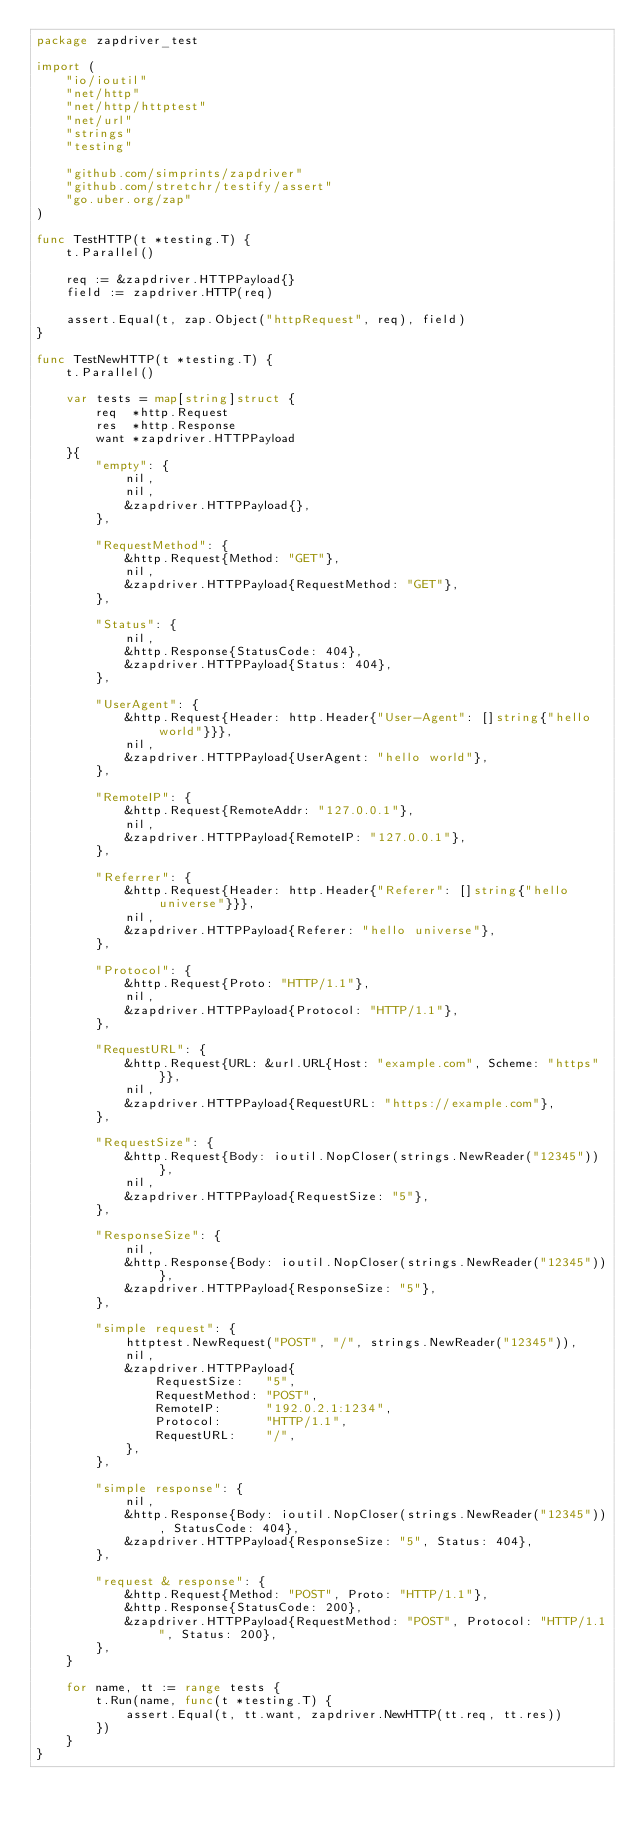<code> <loc_0><loc_0><loc_500><loc_500><_Go_>package zapdriver_test

import (
	"io/ioutil"
	"net/http"
	"net/http/httptest"
	"net/url"
	"strings"
	"testing"

	"github.com/simprints/zapdriver"
	"github.com/stretchr/testify/assert"
	"go.uber.org/zap"
)

func TestHTTP(t *testing.T) {
	t.Parallel()

	req := &zapdriver.HTTPPayload{}
	field := zapdriver.HTTP(req)

	assert.Equal(t, zap.Object("httpRequest", req), field)
}

func TestNewHTTP(t *testing.T) {
	t.Parallel()

	var tests = map[string]struct {
		req  *http.Request
		res  *http.Response
		want *zapdriver.HTTPPayload
	}{
		"empty": {
			nil,
			nil,
			&zapdriver.HTTPPayload{},
		},

		"RequestMethod": {
			&http.Request{Method: "GET"},
			nil,
			&zapdriver.HTTPPayload{RequestMethod: "GET"},
		},

		"Status": {
			nil,
			&http.Response{StatusCode: 404},
			&zapdriver.HTTPPayload{Status: 404},
		},

		"UserAgent": {
			&http.Request{Header: http.Header{"User-Agent": []string{"hello world"}}},
			nil,
			&zapdriver.HTTPPayload{UserAgent: "hello world"},
		},

		"RemoteIP": {
			&http.Request{RemoteAddr: "127.0.0.1"},
			nil,
			&zapdriver.HTTPPayload{RemoteIP: "127.0.0.1"},
		},

		"Referrer": {
			&http.Request{Header: http.Header{"Referer": []string{"hello universe"}}},
			nil,
			&zapdriver.HTTPPayload{Referer: "hello universe"},
		},

		"Protocol": {
			&http.Request{Proto: "HTTP/1.1"},
			nil,
			&zapdriver.HTTPPayload{Protocol: "HTTP/1.1"},
		},

		"RequestURL": {
			&http.Request{URL: &url.URL{Host: "example.com", Scheme: "https"}},
			nil,
			&zapdriver.HTTPPayload{RequestURL: "https://example.com"},
		},

		"RequestSize": {
			&http.Request{Body: ioutil.NopCloser(strings.NewReader("12345"))},
			nil,
			&zapdriver.HTTPPayload{RequestSize: "5"},
		},

		"ResponseSize": {
			nil,
			&http.Response{Body: ioutil.NopCloser(strings.NewReader("12345"))},
			&zapdriver.HTTPPayload{ResponseSize: "5"},
		},

		"simple request": {
			httptest.NewRequest("POST", "/", strings.NewReader("12345")),
			nil,
			&zapdriver.HTTPPayload{
				RequestSize:   "5",
				RequestMethod: "POST",
				RemoteIP:      "192.0.2.1:1234",
				Protocol:      "HTTP/1.1",
				RequestURL:    "/",
			},
		},

		"simple response": {
			nil,
			&http.Response{Body: ioutil.NopCloser(strings.NewReader("12345")), StatusCode: 404},
			&zapdriver.HTTPPayload{ResponseSize: "5", Status: 404},
		},

		"request & response": {
			&http.Request{Method: "POST", Proto: "HTTP/1.1"},
			&http.Response{StatusCode: 200},
			&zapdriver.HTTPPayload{RequestMethod: "POST", Protocol: "HTTP/1.1", Status: 200},
		},
	}

	for name, tt := range tests {
		t.Run(name, func(t *testing.T) {
			assert.Equal(t, tt.want, zapdriver.NewHTTP(tt.req, tt.res))
		})
	}
}
</code> 